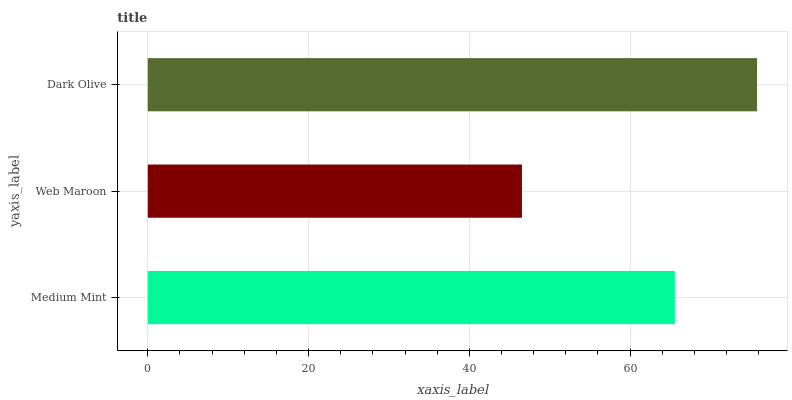Is Web Maroon the minimum?
Answer yes or no. Yes. Is Dark Olive the maximum?
Answer yes or no. Yes. Is Dark Olive the minimum?
Answer yes or no. No. Is Web Maroon the maximum?
Answer yes or no. No. Is Dark Olive greater than Web Maroon?
Answer yes or no. Yes. Is Web Maroon less than Dark Olive?
Answer yes or no. Yes. Is Web Maroon greater than Dark Olive?
Answer yes or no. No. Is Dark Olive less than Web Maroon?
Answer yes or no. No. Is Medium Mint the high median?
Answer yes or no. Yes. Is Medium Mint the low median?
Answer yes or no. Yes. Is Dark Olive the high median?
Answer yes or no. No. Is Dark Olive the low median?
Answer yes or no. No. 